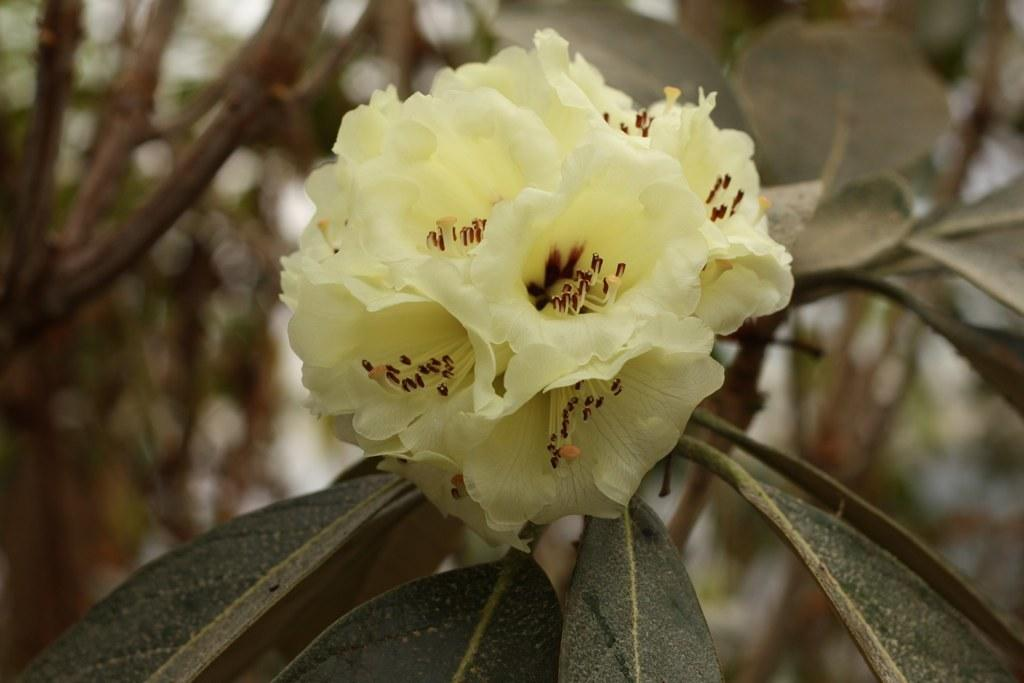What type of living organisms can be seen in the image? There are flowers in the image. What color are the flowers in the image? The flowers are in yellow color. What other part of the plant is visible in the image? There are green leaves in the image. Can you tell me how many strangers are running in the image? There are no strangers or running depicted in the image; it features flowers and green leaves. 